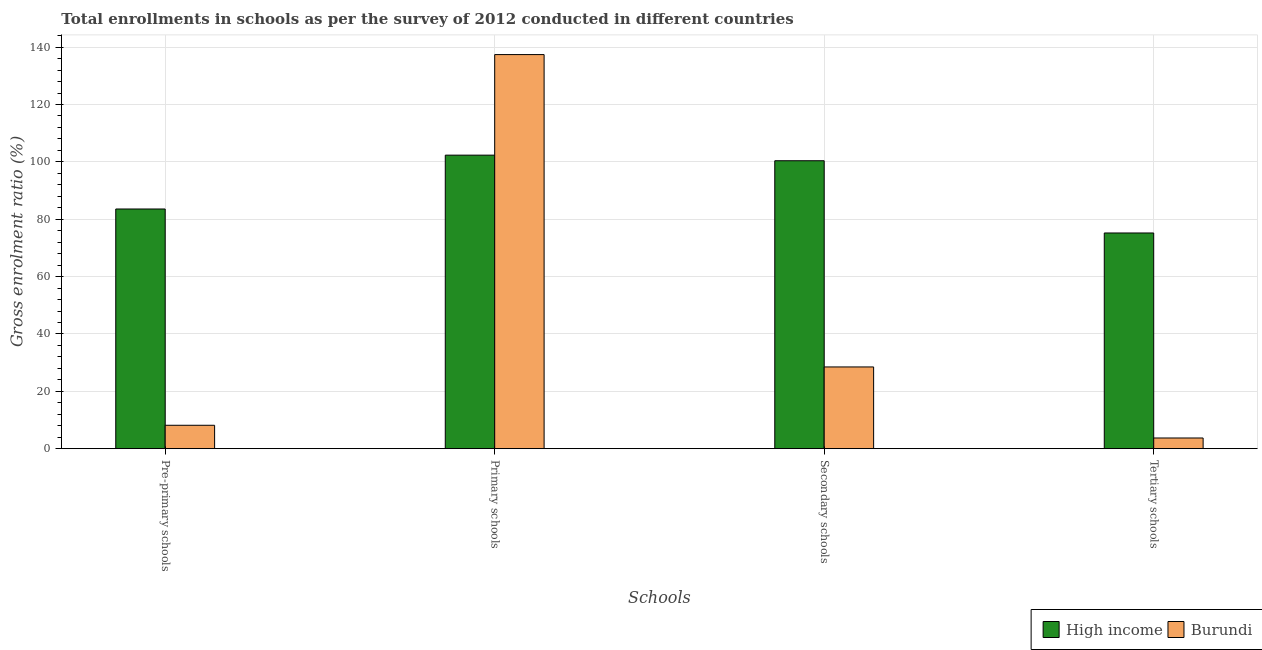How many different coloured bars are there?
Offer a very short reply. 2. How many groups of bars are there?
Your response must be concise. 4. Are the number of bars per tick equal to the number of legend labels?
Ensure brevity in your answer.  Yes. Are the number of bars on each tick of the X-axis equal?
Your answer should be very brief. Yes. How many bars are there on the 4th tick from the left?
Your response must be concise. 2. What is the label of the 1st group of bars from the left?
Provide a short and direct response. Pre-primary schools. What is the gross enrolment ratio in secondary schools in Burundi?
Provide a succinct answer. 28.5. Across all countries, what is the maximum gross enrolment ratio in pre-primary schools?
Provide a succinct answer. 83.57. Across all countries, what is the minimum gross enrolment ratio in secondary schools?
Your response must be concise. 28.5. In which country was the gross enrolment ratio in tertiary schools minimum?
Make the answer very short. Burundi. What is the total gross enrolment ratio in tertiary schools in the graph?
Ensure brevity in your answer.  78.93. What is the difference between the gross enrolment ratio in tertiary schools in Burundi and that in High income?
Keep it short and to the point. -71.49. What is the difference between the gross enrolment ratio in secondary schools in High income and the gross enrolment ratio in pre-primary schools in Burundi?
Offer a terse response. 92.24. What is the average gross enrolment ratio in pre-primary schools per country?
Offer a terse response. 45.87. What is the difference between the gross enrolment ratio in primary schools and gross enrolment ratio in pre-primary schools in High income?
Your answer should be very brief. 18.78. What is the ratio of the gross enrolment ratio in pre-primary schools in High income to that in Burundi?
Make the answer very short. 10.25. Is the difference between the gross enrolment ratio in primary schools in High income and Burundi greater than the difference between the gross enrolment ratio in tertiary schools in High income and Burundi?
Your answer should be very brief. No. What is the difference between the highest and the second highest gross enrolment ratio in primary schools?
Offer a very short reply. 35.07. What is the difference between the highest and the lowest gross enrolment ratio in secondary schools?
Offer a terse response. 71.9. In how many countries, is the gross enrolment ratio in primary schools greater than the average gross enrolment ratio in primary schools taken over all countries?
Give a very brief answer. 1. Is it the case that in every country, the sum of the gross enrolment ratio in tertiary schools and gross enrolment ratio in pre-primary schools is greater than the sum of gross enrolment ratio in primary schools and gross enrolment ratio in secondary schools?
Make the answer very short. No. Is it the case that in every country, the sum of the gross enrolment ratio in pre-primary schools and gross enrolment ratio in primary schools is greater than the gross enrolment ratio in secondary schools?
Keep it short and to the point. Yes. How many countries are there in the graph?
Keep it short and to the point. 2. Does the graph contain any zero values?
Keep it short and to the point. No. Does the graph contain grids?
Give a very brief answer. Yes. Where does the legend appear in the graph?
Provide a short and direct response. Bottom right. How many legend labels are there?
Keep it short and to the point. 2. What is the title of the graph?
Provide a short and direct response. Total enrollments in schools as per the survey of 2012 conducted in different countries. What is the label or title of the X-axis?
Your response must be concise. Schools. What is the Gross enrolment ratio (%) of High income in Pre-primary schools?
Give a very brief answer. 83.57. What is the Gross enrolment ratio (%) in Burundi in Pre-primary schools?
Provide a short and direct response. 8.16. What is the Gross enrolment ratio (%) in High income in Primary schools?
Your answer should be compact. 102.35. What is the Gross enrolment ratio (%) of Burundi in Primary schools?
Ensure brevity in your answer.  137.42. What is the Gross enrolment ratio (%) in High income in Secondary schools?
Your response must be concise. 100.4. What is the Gross enrolment ratio (%) in Burundi in Secondary schools?
Offer a terse response. 28.5. What is the Gross enrolment ratio (%) in High income in Tertiary schools?
Give a very brief answer. 75.21. What is the Gross enrolment ratio (%) of Burundi in Tertiary schools?
Your answer should be compact. 3.72. Across all Schools, what is the maximum Gross enrolment ratio (%) in High income?
Offer a very short reply. 102.35. Across all Schools, what is the maximum Gross enrolment ratio (%) in Burundi?
Give a very brief answer. 137.42. Across all Schools, what is the minimum Gross enrolment ratio (%) of High income?
Your answer should be compact. 75.21. Across all Schools, what is the minimum Gross enrolment ratio (%) of Burundi?
Offer a terse response. 3.72. What is the total Gross enrolment ratio (%) of High income in the graph?
Provide a succinct answer. 361.53. What is the total Gross enrolment ratio (%) in Burundi in the graph?
Ensure brevity in your answer.  177.79. What is the difference between the Gross enrolment ratio (%) in High income in Pre-primary schools and that in Primary schools?
Provide a succinct answer. -18.78. What is the difference between the Gross enrolment ratio (%) in Burundi in Pre-primary schools and that in Primary schools?
Your response must be concise. -129.26. What is the difference between the Gross enrolment ratio (%) in High income in Pre-primary schools and that in Secondary schools?
Give a very brief answer. -16.83. What is the difference between the Gross enrolment ratio (%) of Burundi in Pre-primary schools and that in Secondary schools?
Your answer should be very brief. -20.34. What is the difference between the Gross enrolment ratio (%) in High income in Pre-primary schools and that in Tertiary schools?
Your response must be concise. 8.36. What is the difference between the Gross enrolment ratio (%) in Burundi in Pre-primary schools and that in Tertiary schools?
Your answer should be compact. 4.43. What is the difference between the Gross enrolment ratio (%) of High income in Primary schools and that in Secondary schools?
Ensure brevity in your answer.  1.95. What is the difference between the Gross enrolment ratio (%) in Burundi in Primary schools and that in Secondary schools?
Ensure brevity in your answer.  108.92. What is the difference between the Gross enrolment ratio (%) of High income in Primary schools and that in Tertiary schools?
Your answer should be compact. 27.14. What is the difference between the Gross enrolment ratio (%) of Burundi in Primary schools and that in Tertiary schools?
Your response must be concise. 133.69. What is the difference between the Gross enrolment ratio (%) of High income in Secondary schools and that in Tertiary schools?
Provide a succinct answer. 25.19. What is the difference between the Gross enrolment ratio (%) of Burundi in Secondary schools and that in Tertiary schools?
Provide a short and direct response. 24.77. What is the difference between the Gross enrolment ratio (%) of High income in Pre-primary schools and the Gross enrolment ratio (%) of Burundi in Primary schools?
Keep it short and to the point. -53.84. What is the difference between the Gross enrolment ratio (%) in High income in Pre-primary schools and the Gross enrolment ratio (%) in Burundi in Secondary schools?
Offer a very short reply. 55.08. What is the difference between the Gross enrolment ratio (%) in High income in Pre-primary schools and the Gross enrolment ratio (%) in Burundi in Tertiary schools?
Your answer should be compact. 79.85. What is the difference between the Gross enrolment ratio (%) in High income in Primary schools and the Gross enrolment ratio (%) in Burundi in Secondary schools?
Your response must be concise. 73.85. What is the difference between the Gross enrolment ratio (%) of High income in Primary schools and the Gross enrolment ratio (%) of Burundi in Tertiary schools?
Ensure brevity in your answer.  98.63. What is the difference between the Gross enrolment ratio (%) of High income in Secondary schools and the Gross enrolment ratio (%) of Burundi in Tertiary schools?
Offer a terse response. 96.67. What is the average Gross enrolment ratio (%) in High income per Schools?
Offer a terse response. 90.38. What is the average Gross enrolment ratio (%) of Burundi per Schools?
Give a very brief answer. 44.45. What is the difference between the Gross enrolment ratio (%) in High income and Gross enrolment ratio (%) in Burundi in Pre-primary schools?
Provide a succinct answer. 75.42. What is the difference between the Gross enrolment ratio (%) in High income and Gross enrolment ratio (%) in Burundi in Primary schools?
Give a very brief answer. -35.07. What is the difference between the Gross enrolment ratio (%) in High income and Gross enrolment ratio (%) in Burundi in Secondary schools?
Ensure brevity in your answer.  71.9. What is the difference between the Gross enrolment ratio (%) in High income and Gross enrolment ratio (%) in Burundi in Tertiary schools?
Give a very brief answer. 71.49. What is the ratio of the Gross enrolment ratio (%) in High income in Pre-primary schools to that in Primary schools?
Give a very brief answer. 0.82. What is the ratio of the Gross enrolment ratio (%) in Burundi in Pre-primary schools to that in Primary schools?
Ensure brevity in your answer.  0.06. What is the ratio of the Gross enrolment ratio (%) in High income in Pre-primary schools to that in Secondary schools?
Offer a terse response. 0.83. What is the ratio of the Gross enrolment ratio (%) of Burundi in Pre-primary schools to that in Secondary schools?
Provide a succinct answer. 0.29. What is the ratio of the Gross enrolment ratio (%) of High income in Pre-primary schools to that in Tertiary schools?
Provide a short and direct response. 1.11. What is the ratio of the Gross enrolment ratio (%) in Burundi in Pre-primary schools to that in Tertiary schools?
Give a very brief answer. 2.19. What is the ratio of the Gross enrolment ratio (%) of High income in Primary schools to that in Secondary schools?
Offer a very short reply. 1.02. What is the ratio of the Gross enrolment ratio (%) in Burundi in Primary schools to that in Secondary schools?
Offer a terse response. 4.82. What is the ratio of the Gross enrolment ratio (%) of High income in Primary schools to that in Tertiary schools?
Offer a terse response. 1.36. What is the ratio of the Gross enrolment ratio (%) of Burundi in Primary schools to that in Tertiary schools?
Keep it short and to the point. 36.9. What is the ratio of the Gross enrolment ratio (%) of High income in Secondary schools to that in Tertiary schools?
Provide a succinct answer. 1.33. What is the ratio of the Gross enrolment ratio (%) of Burundi in Secondary schools to that in Tertiary schools?
Keep it short and to the point. 7.65. What is the difference between the highest and the second highest Gross enrolment ratio (%) of High income?
Make the answer very short. 1.95. What is the difference between the highest and the second highest Gross enrolment ratio (%) of Burundi?
Give a very brief answer. 108.92. What is the difference between the highest and the lowest Gross enrolment ratio (%) of High income?
Your answer should be very brief. 27.14. What is the difference between the highest and the lowest Gross enrolment ratio (%) of Burundi?
Ensure brevity in your answer.  133.69. 